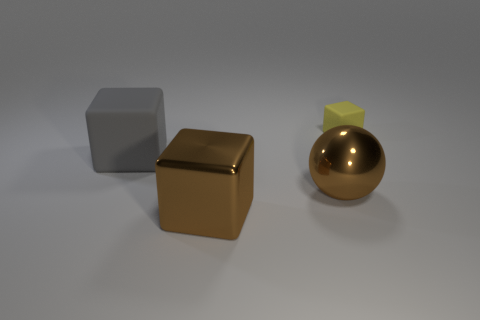Add 3 large brown shiny objects. How many objects exist? 7 Subtract all blocks. How many objects are left? 1 Add 1 metal cubes. How many metal cubes are left? 2 Add 4 big brown metallic blocks. How many big brown metallic blocks exist? 5 Subtract 0 yellow cylinders. How many objects are left? 4 Subtract all purple metal things. Subtract all brown spheres. How many objects are left? 3 